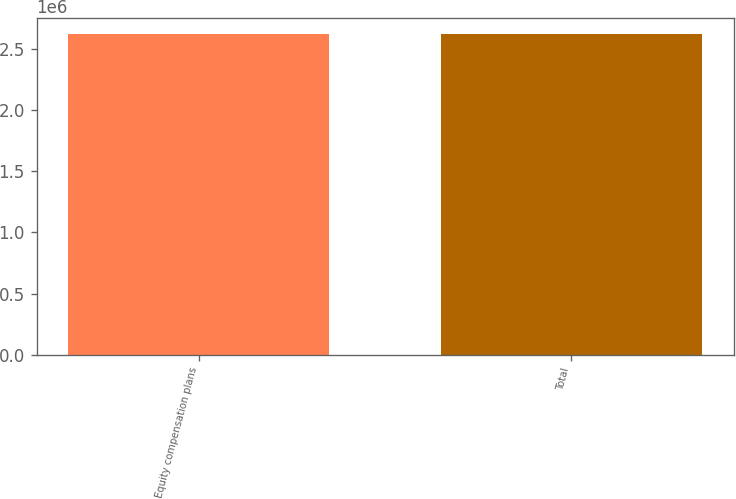Convert chart to OTSL. <chart><loc_0><loc_0><loc_500><loc_500><bar_chart><fcel>Equity compensation plans<fcel>Total<nl><fcel>2.62202e+06<fcel>2.62202e+06<nl></chart> 